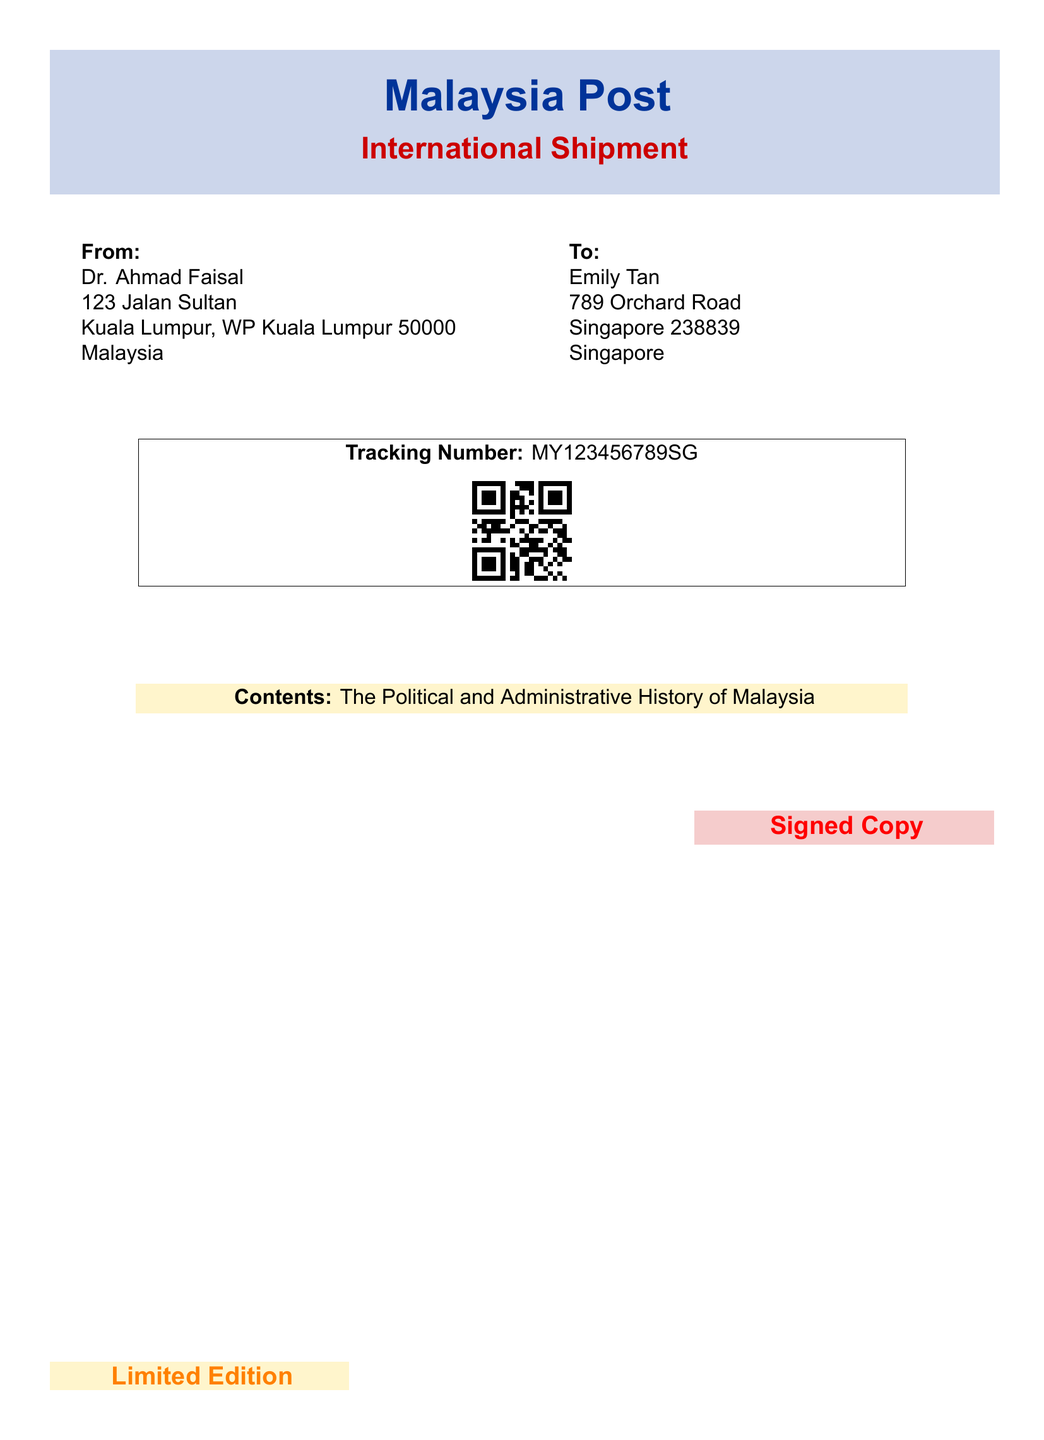What is the sender's name? The sender's name is listed at the top of the label.
Answer: Dr. Ahmad Faisal Where is the sender located? The sender's address is provided on the left side of the label.
Answer: Kuala Lumpur, WP Kuala Lumpur 50000, Malaysia What is the recipient's city? The recipient's city can be found in the address details on the right side.
Answer: Singapore What is the tracking number? The tracking number is displayed within a box in the center of the label.
Answer: MY123456789SG What type of copies are being shipped? The special designation of the copies is provided in the promotional section towards the bottom right.
Answer: Signed Copy What is the edition status? The edition status is mentioned in the promotion at the bottom left of the label.
Answer: Limited Edition What is the title of the contents? The title of the book being shipped is specified in the contents section.
Answer: The Political and Administrative History of Malaysia What color is used for the "International Shipment" label? The color associated with the "International Shipment" text can be observed in the color box.
Answer: Malaysia red What additional feature is included with the tracking number? There is a visual element that accompanies the tracking information on the label.
Answer: QR code What document type is this? The overall layout and purpose of the document identifies its category.
Answer: Shipping label 